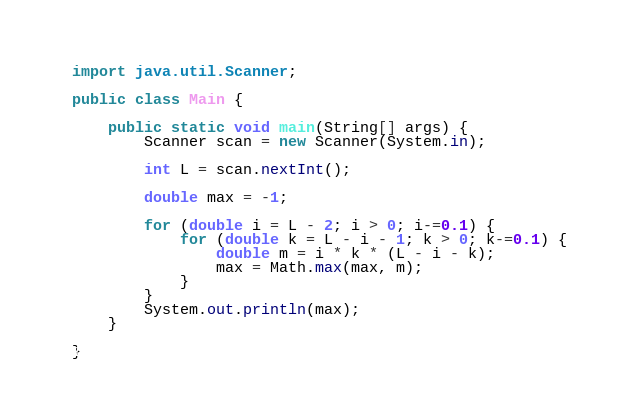<code> <loc_0><loc_0><loc_500><loc_500><_Java_>import java.util.Scanner;

public class Main {

	public static void main(String[] args) {
		Scanner scan = new Scanner(System.in);
		
		int L = scan.nextInt();

		double max = -1;
		
		for (double i = L - 2; i > 0; i-=0.1) {
			for (double k = L - i - 1; k > 0; k-=0.1) {
				double m = i * k * (L - i - k);
				max = Math.max(max, m);
			}
		}
		System.out.println(max);
	}

}
</code> 